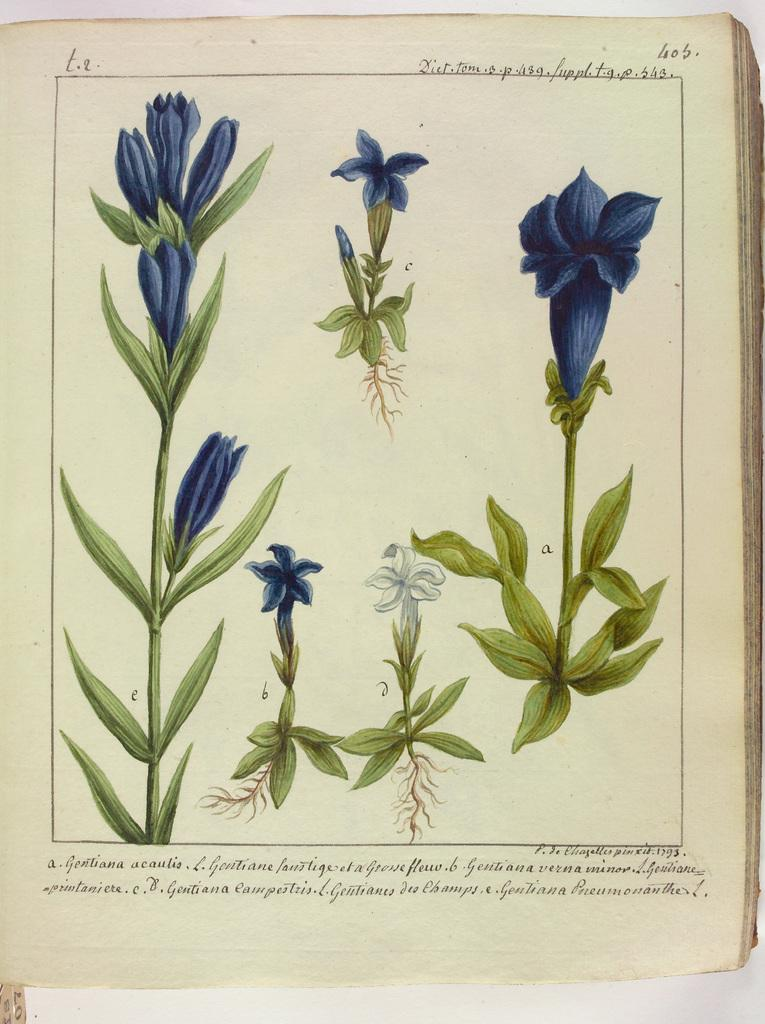What is present on the book in the image? There is a book in the image, and it has plants with flowers on it. Can you describe the text visible on the book? Yes, there is text visible on the book. What else can be seen on the book besides the plants with flowers? There is text visible on the book. What type of lumber is being used to construct the horse in the image? There is no horse or lumber present in the image; it features a book with plants and flowers on it. 